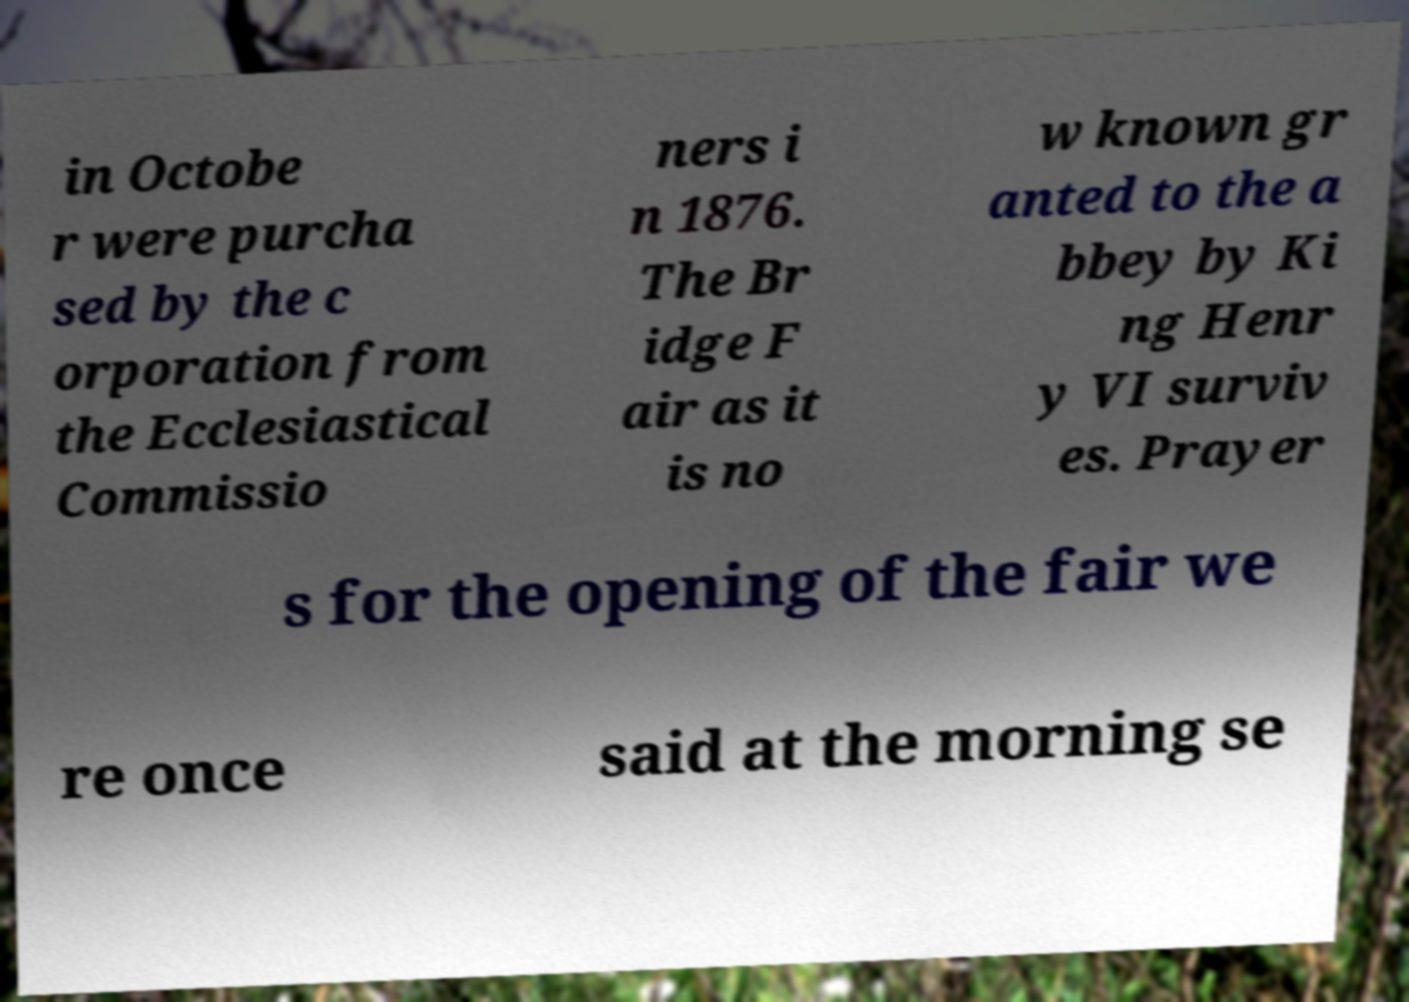There's text embedded in this image that I need extracted. Can you transcribe it verbatim? in Octobe r were purcha sed by the c orporation from the Ecclesiastical Commissio ners i n 1876. The Br idge F air as it is no w known gr anted to the a bbey by Ki ng Henr y VI surviv es. Prayer s for the opening of the fair we re once said at the morning se 